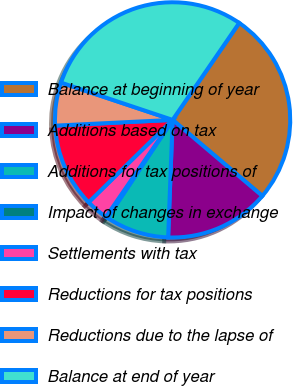<chart> <loc_0><loc_0><loc_500><loc_500><pie_chart><fcel>Balance at beginning of year<fcel>Additions based on tax<fcel>Additions for tax positions of<fcel>Impact of changes in exchange<fcel>Settlements with tax<fcel>Reductions for tax positions<fcel>Reductions due to the lapse of<fcel>Balance at end of year<nl><fcel>26.61%<fcel>14.41%<fcel>8.74%<fcel>0.24%<fcel>3.07%<fcel>11.57%<fcel>5.91%<fcel>29.45%<nl></chart> 